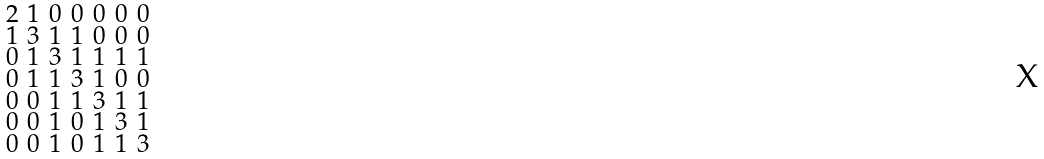<formula> <loc_0><loc_0><loc_500><loc_500>\begin{smallmatrix} 2 & 1 & 0 & 0 & 0 & 0 & 0 \\ 1 & 3 & 1 & 1 & 0 & 0 & 0 \\ 0 & 1 & 3 & 1 & 1 & 1 & 1 \\ 0 & 1 & 1 & 3 & 1 & 0 & 0 \\ 0 & 0 & 1 & 1 & 3 & 1 & 1 \\ 0 & 0 & 1 & 0 & 1 & 3 & 1 \\ 0 & 0 & 1 & 0 & 1 & 1 & 3 \end{smallmatrix}</formula> 